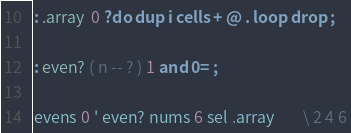Convert code to text. <code><loc_0><loc_0><loc_500><loc_500><_Forth_>
: .array  0 ?do dup i cells + @ . loop drop ;

: even? ( n -- ? ) 1 and 0= ;

evens 0 ' even? nums 6 sel .array        \ 2 4 6
</code> 